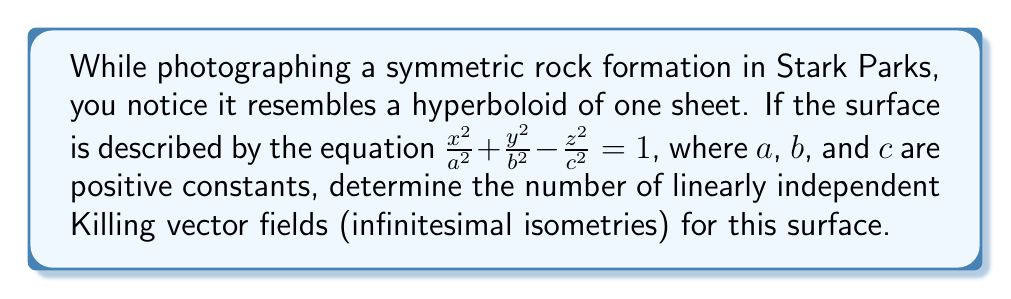Can you solve this math problem? To analyze the symmetry of this natural formation using differential forms, we'll follow these steps:

1) First, recall that Killing vector fields represent the infinitesimal generators of isometries (symmetries) of a manifold.

2) For a hyperboloid of one sheet, we need to consider its symmetries:
   - Rotational symmetry around the z-axis
   - Reflection symmetry in the xy-plane
   - Hyperbolic rotations in the xz and yz planes

3) Let's express these symmetries as Killing vector fields:

   a) Rotation around z-axis: $X_1 = y\frac{\partial}{\partial x} - x\frac{\partial}{\partial y}$

   b) Hyperbolic rotation in xz-plane: $X_2 = z\frac{\partial}{\partial x} + x\frac{\partial}{\partial z}$

   c) Hyperbolic rotation in yz-plane: $X_3 = z\frac{\partial}{\partial y} + y\frac{\partial}{\partial z}$

4) These three vector fields are linearly independent and generate all the continuous symmetries of the hyperboloid.

5) The reflection symmetry in the xy-plane doesn't contribute an additional linearly independent Killing vector field, as it's discrete.

Therefore, the hyperboloid of one sheet has 3 linearly independent Killing vector fields.
Answer: 3 